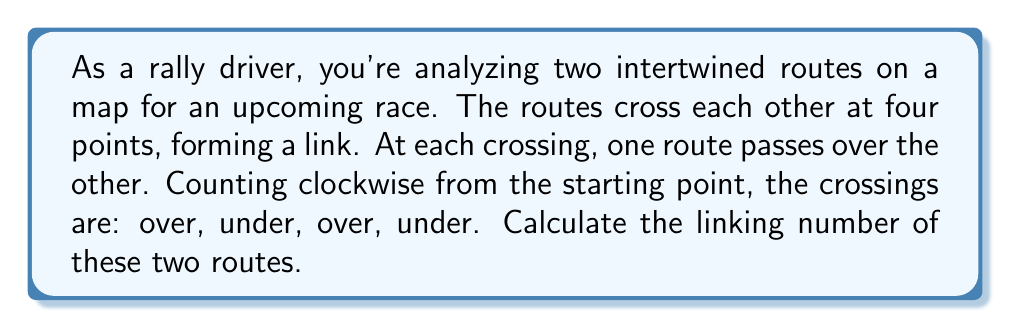Teach me how to tackle this problem. To solve this problem, we'll follow these steps:

1) In knot theory, the linking number is a numerical invariant that describes how two closed curves are linked in three-dimensional space. For a two-dimensional projection (like our map), we can calculate it using crossings.

2) Each crossing is assigned a value of +1 or -1 based on its orientation:
   - +1 if the upper strand crosses from left to right
   - -1 if the upper strand crosses from right to left

3) Let's analyze our crossings:
   - 1st crossing (over): +1
   - 2nd crossing (under): 0 (we don't count when our route goes under)
   - 3rd crossing (over): +1
   - 4th crossing (under): 0

4) The linking number is calculated as:

   $$ \text{Linking Number} = \frac{1}{2} \sum \text{(crossing values)} $$

5) Summing our crossing values:
   $$ \sum \text{(crossing values)} = 1 + 0 + 1 + 0 = 2 $$

6) Applying the formula:
   $$ \text{Linking Number} = \frac{1}{2} (2) = 1 $$

Therefore, the linking number of the two rally routes is 1.
Answer: 1 